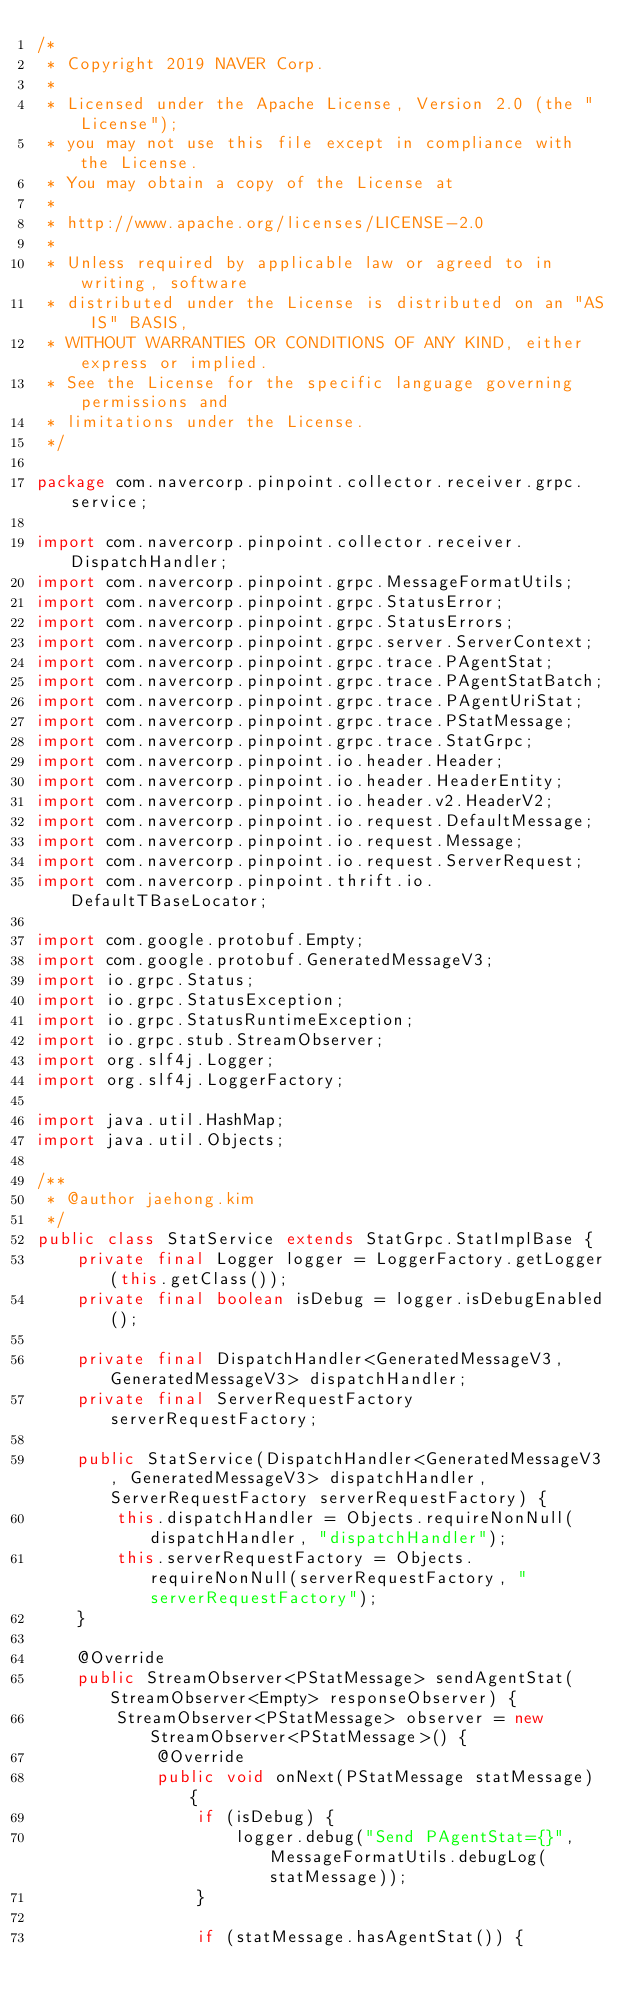Convert code to text. <code><loc_0><loc_0><loc_500><loc_500><_Java_>/*
 * Copyright 2019 NAVER Corp.
 *
 * Licensed under the Apache License, Version 2.0 (the "License");
 * you may not use this file except in compliance with the License.
 * You may obtain a copy of the License at
 *
 * http://www.apache.org/licenses/LICENSE-2.0
 *
 * Unless required by applicable law or agreed to in writing, software
 * distributed under the License is distributed on an "AS IS" BASIS,
 * WITHOUT WARRANTIES OR CONDITIONS OF ANY KIND, either express or implied.
 * See the License for the specific language governing permissions and
 * limitations under the License.
 */

package com.navercorp.pinpoint.collector.receiver.grpc.service;

import com.navercorp.pinpoint.collector.receiver.DispatchHandler;
import com.navercorp.pinpoint.grpc.MessageFormatUtils;
import com.navercorp.pinpoint.grpc.StatusError;
import com.navercorp.pinpoint.grpc.StatusErrors;
import com.navercorp.pinpoint.grpc.server.ServerContext;
import com.navercorp.pinpoint.grpc.trace.PAgentStat;
import com.navercorp.pinpoint.grpc.trace.PAgentStatBatch;
import com.navercorp.pinpoint.grpc.trace.PAgentUriStat;
import com.navercorp.pinpoint.grpc.trace.PStatMessage;
import com.navercorp.pinpoint.grpc.trace.StatGrpc;
import com.navercorp.pinpoint.io.header.Header;
import com.navercorp.pinpoint.io.header.HeaderEntity;
import com.navercorp.pinpoint.io.header.v2.HeaderV2;
import com.navercorp.pinpoint.io.request.DefaultMessage;
import com.navercorp.pinpoint.io.request.Message;
import com.navercorp.pinpoint.io.request.ServerRequest;
import com.navercorp.pinpoint.thrift.io.DefaultTBaseLocator;

import com.google.protobuf.Empty;
import com.google.protobuf.GeneratedMessageV3;
import io.grpc.Status;
import io.grpc.StatusException;
import io.grpc.StatusRuntimeException;
import io.grpc.stub.StreamObserver;
import org.slf4j.Logger;
import org.slf4j.LoggerFactory;

import java.util.HashMap;
import java.util.Objects;

/**
 * @author jaehong.kim
 */
public class StatService extends StatGrpc.StatImplBase {
    private final Logger logger = LoggerFactory.getLogger(this.getClass());
    private final boolean isDebug = logger.isDebugEnabled();

    private final DispatchHandler<GeneratedMessageV3, GeneratedMessageV3> dispatchHandler;
    private final ServerRequestFactory serverRequestFactory;

    public StatService(DispatchHandler<GeneratedMessageV3, GeneratedMessageV3> dispatchHandler, ServerRequestFactory serverRequestFactory) {
        this.dispatchHandler = Objects.requireNonNull(dispatchHandler, "dispatchHandler");
        this.serverRequestFactory = Objects.requireNonNull(serverRequestFactory, "serverRequestFactory");
    }

    @Override
    public StreamObserver<PStatMessage> sendAgentStat(StreamObserver<Empty> responseObserver) {
        StreamObserver<PStatMessage> observer = new StreamObserver<PStatMessage>() {
            @Override
            public void onNext(PStatMessage statMessage) {
                if (isDebug) {
                    logger.debug("Send PAgentStat={}", MessageFormatUtils.debugLog(statMessage));
                }

                if (statMessage.hasAgentStat()) {</code> 